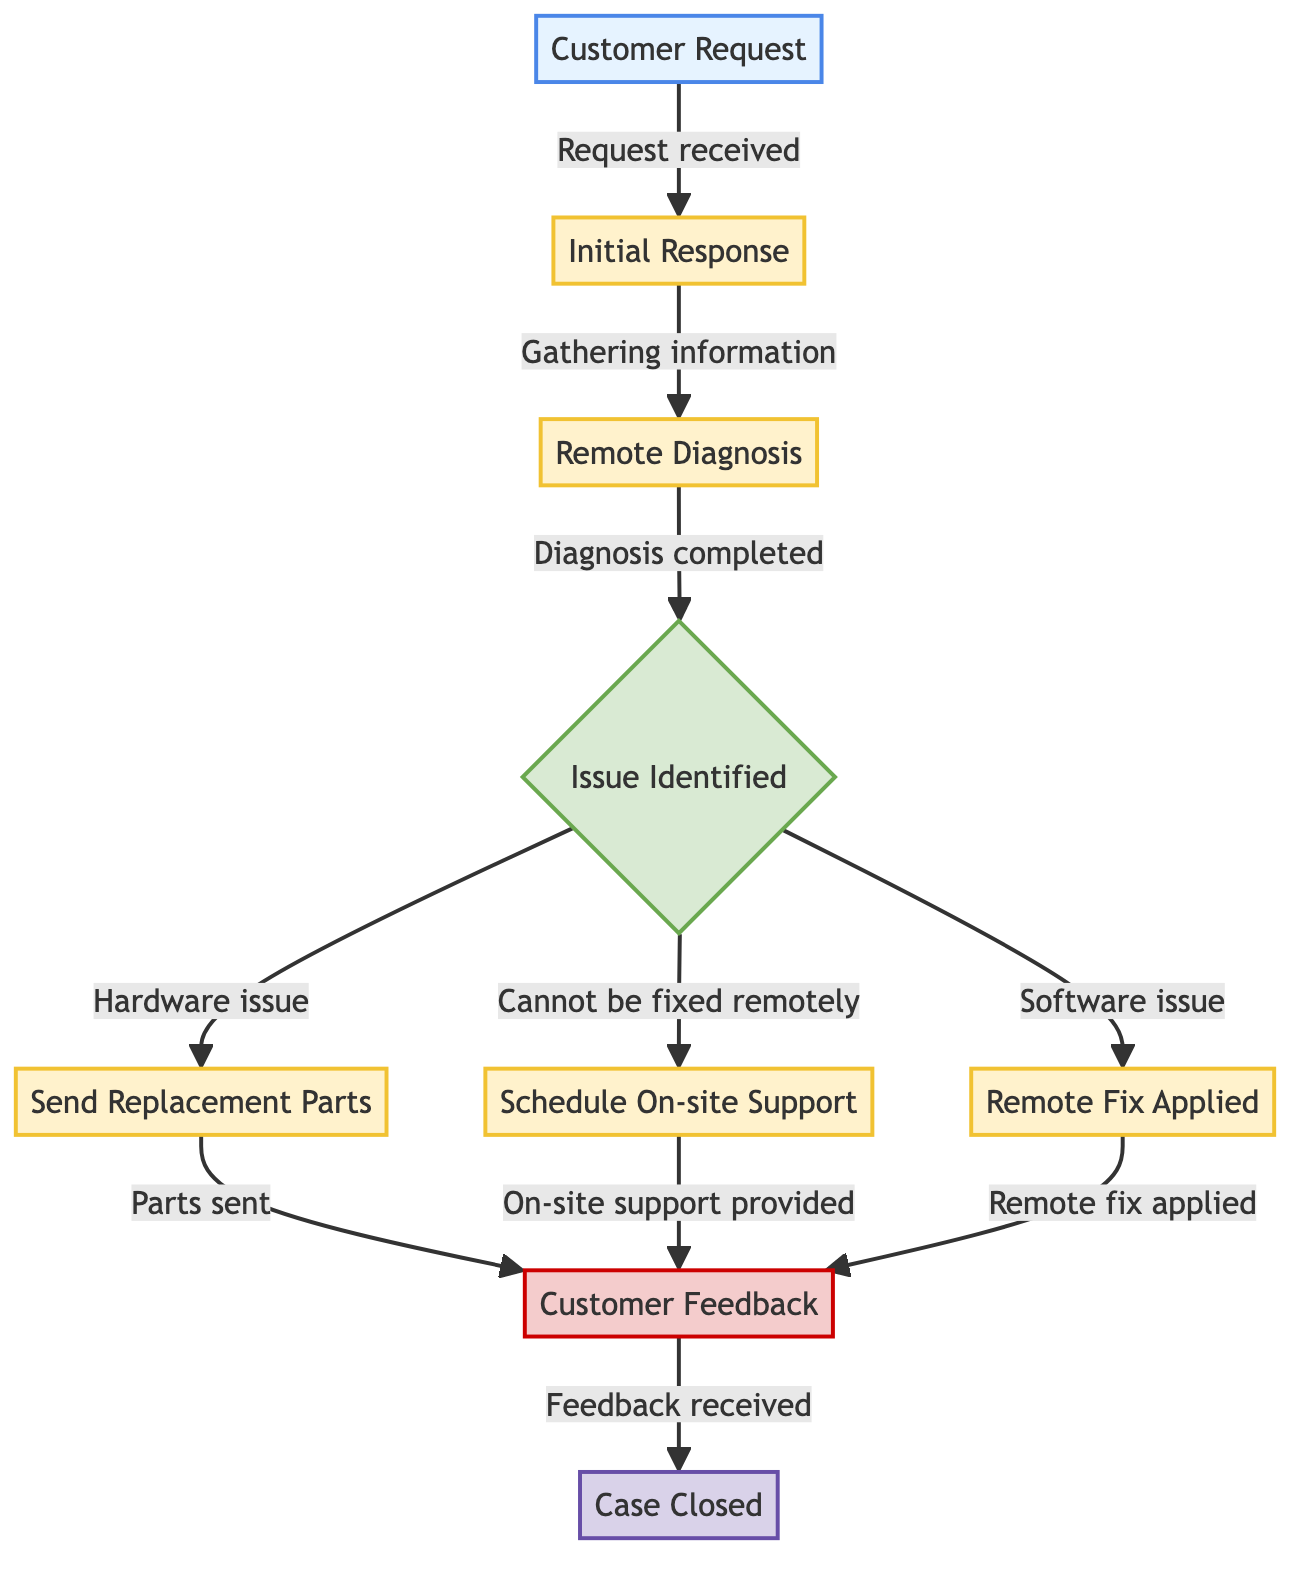What is the first node in the workflow? The first node in the workflow is labeled "Customer Request." This information can be found at the top of the diagram, indicating the starting point for the customer support process.
Answer: Customer Request How many decision nodes are present in the diagram? The diagram contains one decision node, which is labeled "Issue Identified." It is used to determine the course of action based on whether the issue is hardware or software related.
Answer: One What follows the "Initial Response" in the workflow? After the "Initial Response," the next step in the workflow is "Remote Diagnosis." This connection is shown in the links section that follows the initial response node.
Answer: Remote Diagnosis What action is taken if a hardware issue is identified? If a hardware issue is identified, the next action taken is to "Send Replacement Parts." This can be seen as the flow leads from the decision node labeled "Issue Identified" to the process labeled "Send Replacement Parts."
Answer: Send Replacement Parts What happens after "Customer Feedback" is received? After "Customer Feedback" is received, the final action taken in the workflow is to close the case, represented by the node labeled "Case Closed." This signifies the completion of the customer support process.
Answer: Case Closed If a software issue is identified, what is done next? If a software issue is identified, the next action is "Remote Fix Applied." This is a direct consequence of the decision made at the "Issue Identified" node when the condition for a software issue is satisfied.
Answer: Remote Fix Applied What is the connection between "Schedule On-site Support" and "Customer Feedback"? The connection between "Schedule On-site Support" and "Customer Feedback" is that on-site support provided leads to customer feedback. This relationship indicates that customer feedback is gathered after the support service is delivered.
Answer: On-site support provided What type of node is "Issue Identified"? The node labeled "Issue Identified" is a decision node. This classification can be inferred from its unique shape and role in determining the subsequent actions based on the diagnosis.
Answer: Decision node 